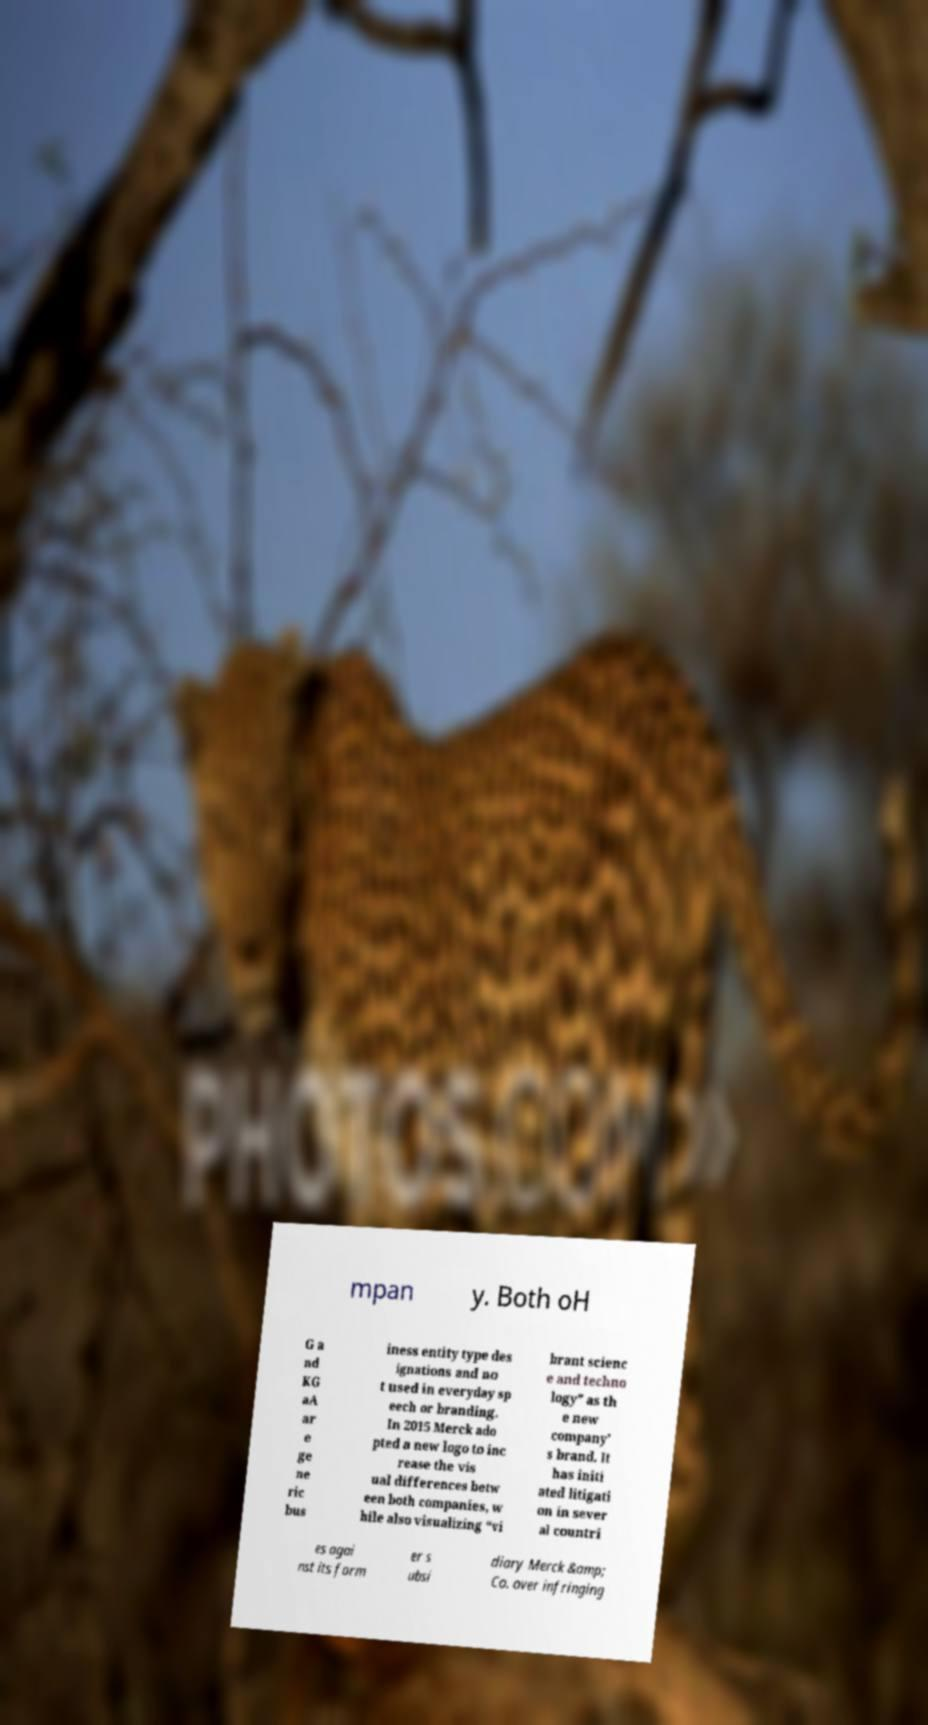Please identify and transcribe the text found in this image. mpan y. Both oH G a nd KG aA ar e ge ne ric bus iness entity type des ignations and no t used in everyday sp eech or branding. In 2015 Merck ado pted a new logo to inc rease the vis ual differences betw een both companies, w hile also visualizing “vi brant scienc e and techno logy” as th e new company’ s brand. It has initi ated litigati on in sever al countri es agai nst its form er s ubsi diary Merck &amp; Co. over infringing 